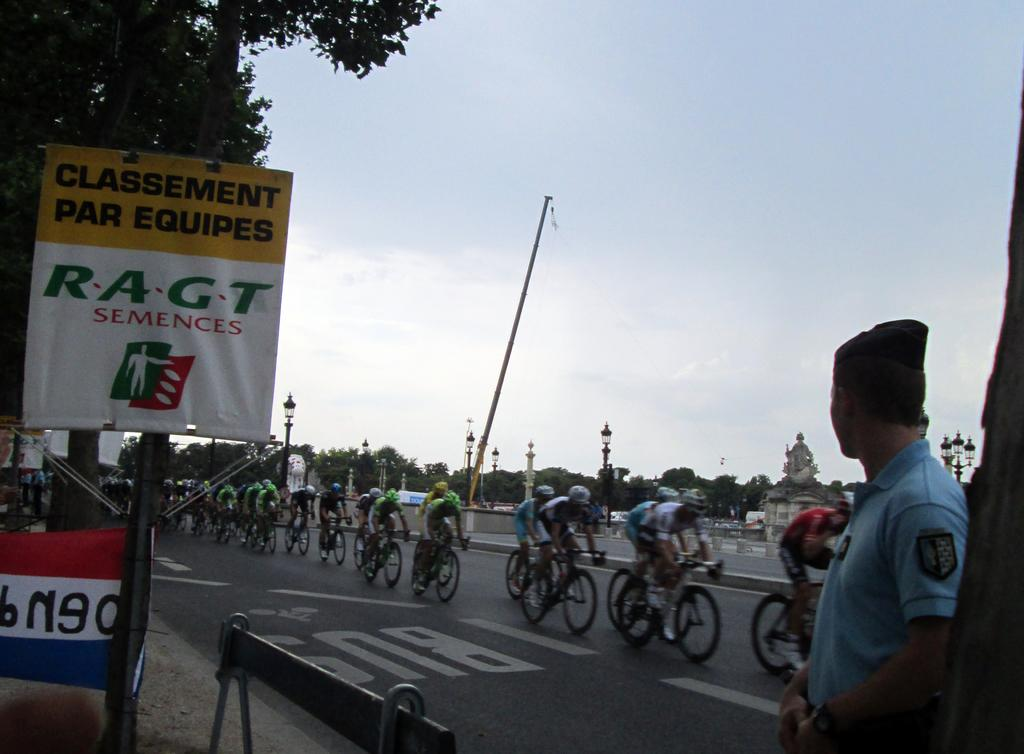What are the people in the image doing? There is a group of people riding bicycles on the road in the image. Can you describe the person who is not riding a bicycle? There is a person watching the group of cyclists in the image. What can be seen in the background of the image? Trees, a pole, the sky, and a banner are visible in the background of the image. What is the topic of the argument taking place between the cyclists in the image? There is no argument taking place between the cyclists in the image; they are simply riding bicycles. What type of board is being used by the cyclists in the image? There is no board present in the image; the cyclists are riding bicycles. 